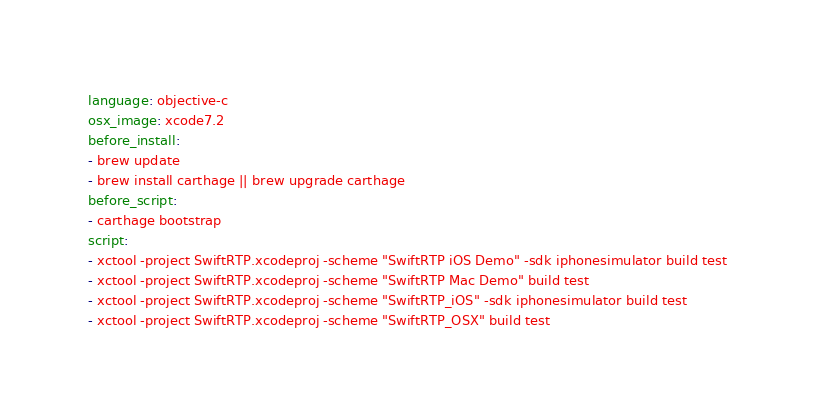Convert code to text. <code><loc_0><loc_0><loc_500><loc_500><_YAML_>language: objective-c
osx_image: xcode7.2
before_install:
- brew update
- brew install carthage || brew upgrade carthage
before_script:
- carthage bootstrap
script:
- xctool -project SwiftRTP.xcodeproj -scheme "SwiftRTP iOS Demo" -sdk iphonesimulator build test
- xctool -project SwiftRTP.xcodeproj -scheme "SwiftRTP Mac Demo" build test
- xctool -project SwiftRTP.xcodeproj -scheme "SwiftRTP_iOS" -sdk iphonesimulator build test
- xctool -project SwiftRTP.xcodeproj -scheme "SwiftRTP_OSX" build test

</code> 